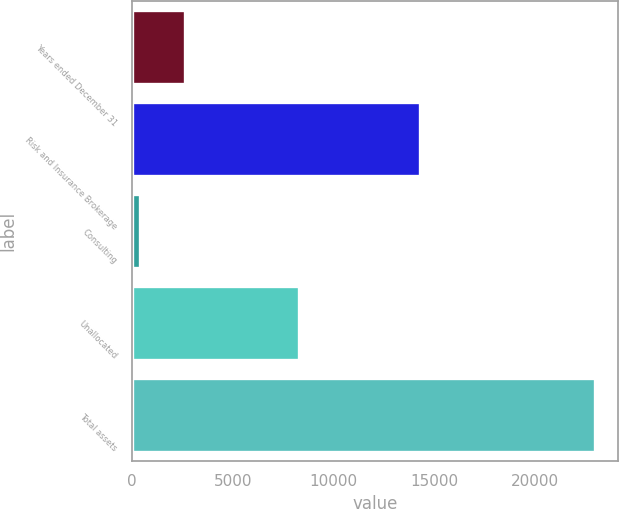<chart> <loc_0><loc_0><loc_500><loc_500><bar_chart><fcel>Years ended December 31<fcel>Risk and Insurance Brokerage<fcel>Consulting<fcel>Unallocated<fcel>Total assets<nl><fcel>2635.1<fcel>14285<fcel>379<fcel>8276<fcel>22940<nl></chart> 